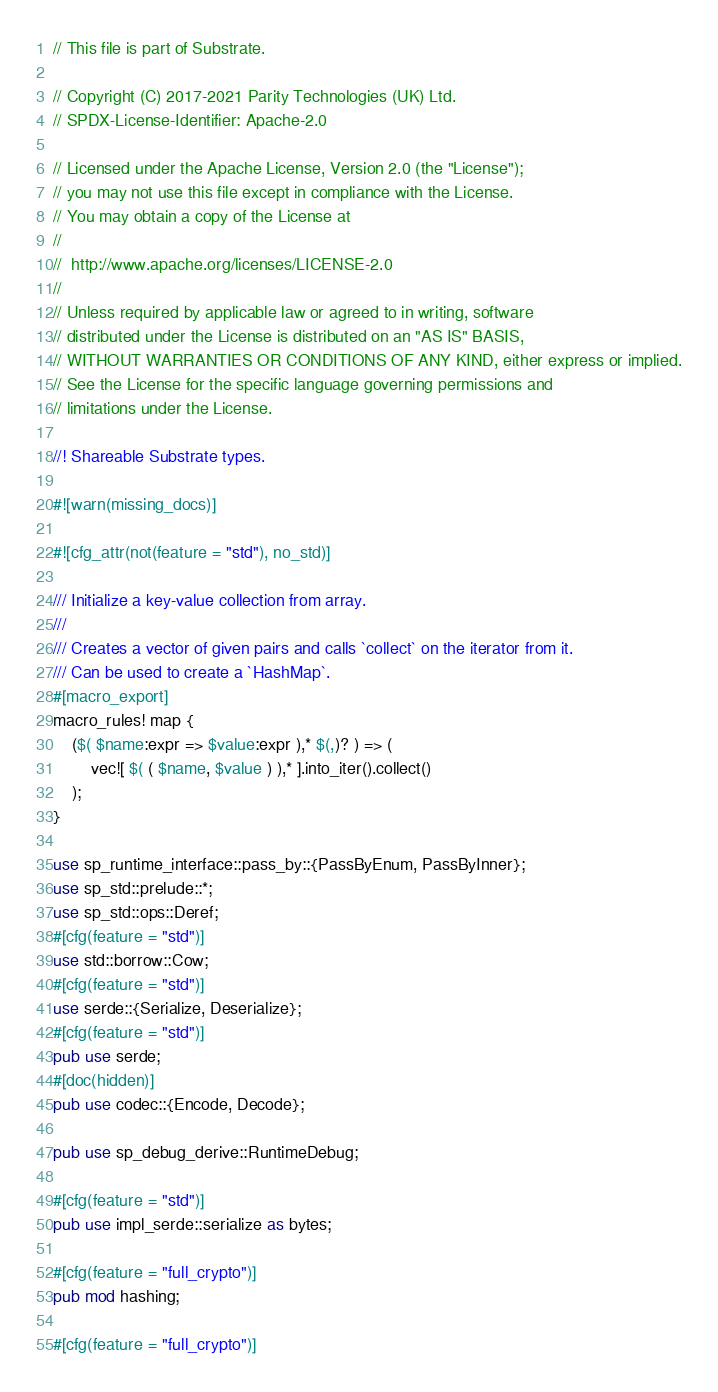<code> <loc_0><loc_0><loc_500><loc_500><_Rust_>// This file is part of Substrate.

// Copyright (C) 2017-2021 Parity Technologies (UK) Ltd.
// SPDX-License-Identifier: Apache-2.0

// Licensed under the Apache License, Version 2.0 (the "License");
// you may not use this file except in compliance with the License.
// You may obtain a copy of the License at
//
// 	http://www.apache.org/licenses/LICENSE-2.0
//
// Unless required by applicable law or agreed to in writing, software
// distributed under the License is distributed on an "AS IS" BASIS,
// WITHOUT WARRANTIES OR CONDITIONS OF ANY KIND, either express or implied.
// See the License for the specific language governing permissions and
// limitations under the License.

//! Shareable Substrate types.

#![warn(missing_docs)]

#![cfg_attr(not(feature = "std"), no_std)]

/// Initialize a key-value collection from array.
///
/// Creates a vector of given pairs and calls `collect` on the iterator from it.
/// Can be used to create a `HashMap`.
#[macro_export]
macro_rules! map {
	($( $name:expr => $value:expr ),* $(,)? ) => (
		vec![ $( ( $name, $value ) ),* ].into_iter().collect()
	);
}

use sp_runtime_interface::pass_by::{PassByEnum, PassByInner};
use sp_std::prelude::*;
use sp_std::ops::Deref;
#[cfg(feature = "std")]
use std::borrow::Cow;
#[cfg(feature = "std")]
use serde::{Serialize, Deserialize};
#[cfg(feature = "std")]
pub use serde;
#[doc(hidden)]
pub use codec::{Encode, Decode};

pub use sp_debug_derive::RuntimeDebug;

#[cfg(feature = "std")]
pub use impl_serde::serialize as bytes;

#[cfg(feature = "full_crypto")]
pub mod hashing;

#[cfg(feature = "full_crypto")]</code> 